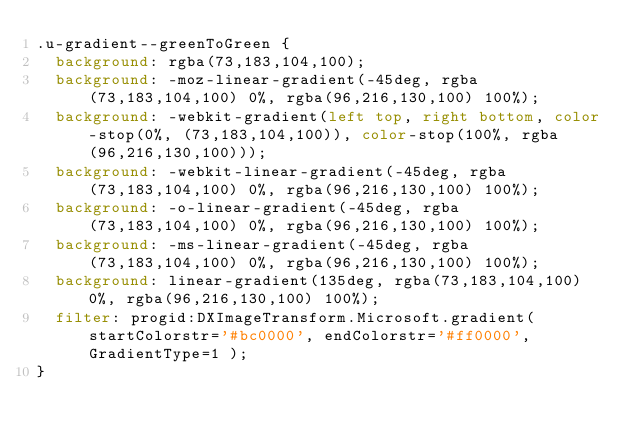Convert code to text. <code><loc_0><loc_0><loc_500><loc_500><_CSS_>.u-gradient--greenToGreen {
  background: rgba(73,183,104,100);
  background: -moz-linear-gradient(-45deg, rgba(73,183,104,100) 0%, rgba(96,216,130,100) 100%);
  background: -webkit-gradient(left top, right bottom, color-stop(0%, (73,183,104,100)), color-stop(100%, rgba(96,216,130,100)));
  background: -webkit-linear-gradient(-45deg, rgba(73,183,104,100) 0%, rgba(96,216,130,100) 100%);
  background: -o-linear-gradient(-45deg, rgba(73,183,104,100) 0%, rgba(96,216,130,100) 100%);
  background: -ms-linear-gradient(-45deg, rgba(73,183,104,100) 0%, rgba(96,216,130,100) 100%);
  background: linear-gradient(135deg, rgba(73,183,104,100) 0%, rgba(96,216,130,100) 100%);
  filter: progid:DXImageTransform.Microsoft.gradient( startColorstr='#bc0000', endColorstr='#ff0000', GradientType=1 );
}
</code> 